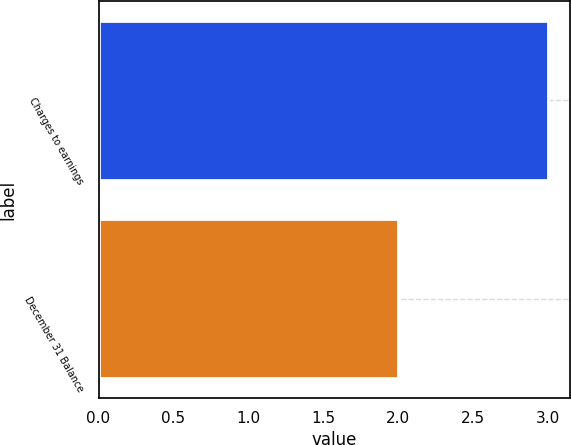<chart> <loc_0><loc_0><loc_500><loc_500><bar_chart><fcel>Charges to earnings<fcel>December 31 Balance<nl><fcel>3<fcel>2<nl></chart> 